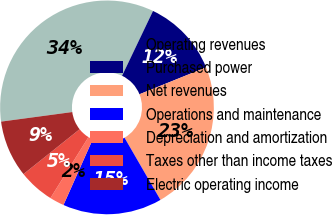<chart> <loc_0><loc_0><loc_500><loc_500><pie_chart><fcel>Operating revenues<fcel>Purchased power<fcel>Net revenues<fcel>Operations and maintenance<fcel>Depreciation and amortization<fcel>Taxes other than income taxes<fcel>Electric operating income<nl><fcel>34.22%<fcel>11.8%<fcel>22.77%<fcel>15.01%<fcel>2.2%<fcel>5.4%<fcel>8.6%<nl></chart> 